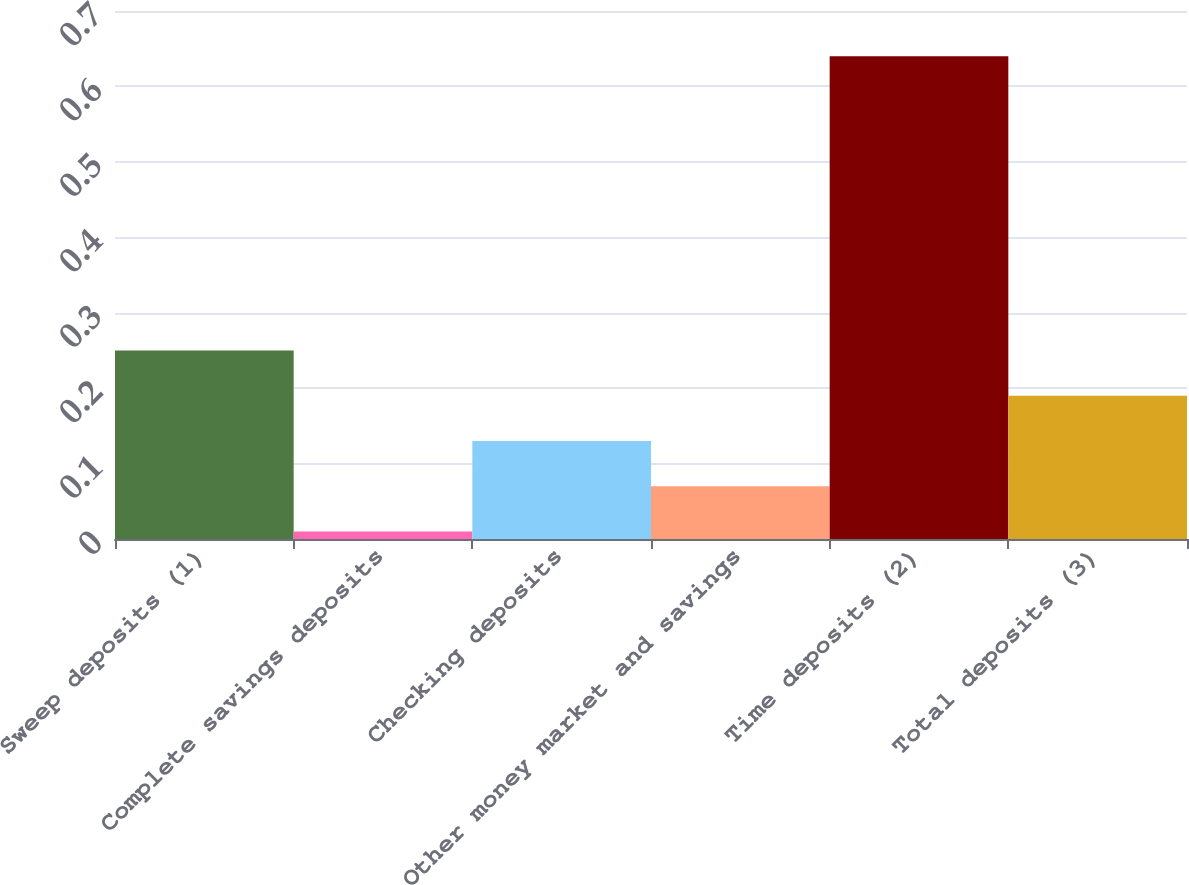Convert chart to OTSL. <chart><loc_0><loc_0><loc_500><loc_500><bar_chart><fcel>Sweep deposits (1)<fcel>Complete savings deposits<fcel>Checking deposits<fcel>Other money market and savings<fcel>Time deposits (2)<fcel>Total deposits (3)<nl><fcel>0.25<fcel>0.01<fcel>0.13<fcel>0.07<fcel>0.64<fcel>0.19<nl></chart> 